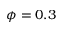<formula> <loc_0><loc_0><loc_500><loc_500>\phi = 0 . 3</formula> 